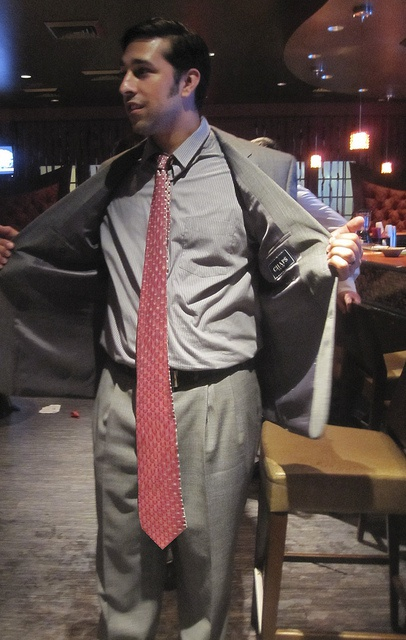Describe the objects in this image and their specific colors. I can see people in navy, black, darkgray, gray, and brown tones, chair in navy, black, gray, and tan tones, tie in navy, brown, salmon, lightpink, and darkgray tones, chair in navy, black, maroon, and olive tones, and bowl in navy, maroon, tan, and brown tones in this image. 